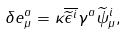Convert formula to latex. <formula><loc_0><loc_0><loc_500><loc_500>\delta e _ { \mu } ^ { a } = \kappa \overline { \widetilde { \epsilon } ^ { i } } \gamma ^ { a } \widetilde { \psi } _ { \mu } ^ { i } ,</formula> 